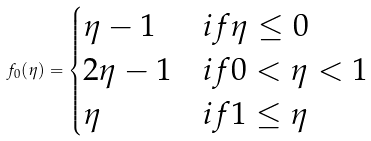<formula> <loc_0><loc_0><loc_500><loc_500>f _ { 0 } ( \eta ) = \begin{cases} \eta - 1 & i f \eta \leq 0 \\ 2 \eta - 1 & i f 0 < \eta < 1 \\ \eta & i f 1 \leq \eta \end{cases}</formula> 